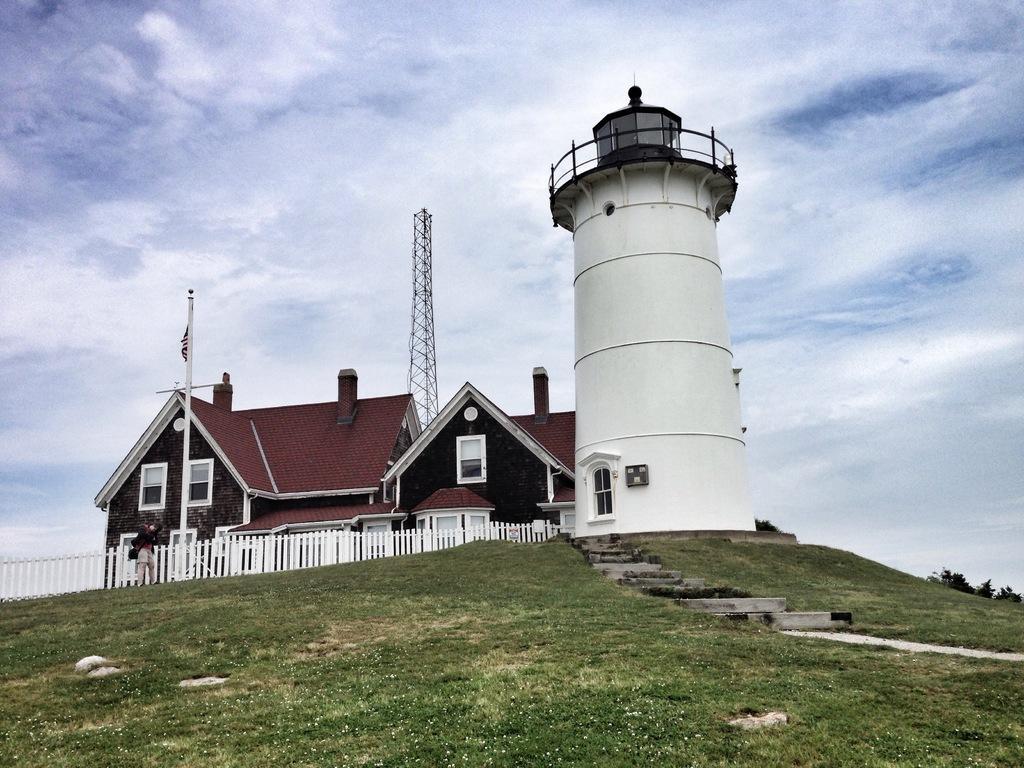Could you give a brief overview of what you see in this image? At the bottom of the there is grass. In the middle of the image there is a house and there is a fencing and a man is standing and holding a camera. Behind the house there are some clouds and sky. 